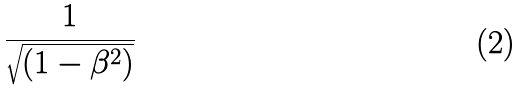<formula> <loc_0><loc_0><loc_500><loc_500>\frac { 1 } { \sqrt { ( 1 - \beta ^ { 2 } ) } }</formula> 